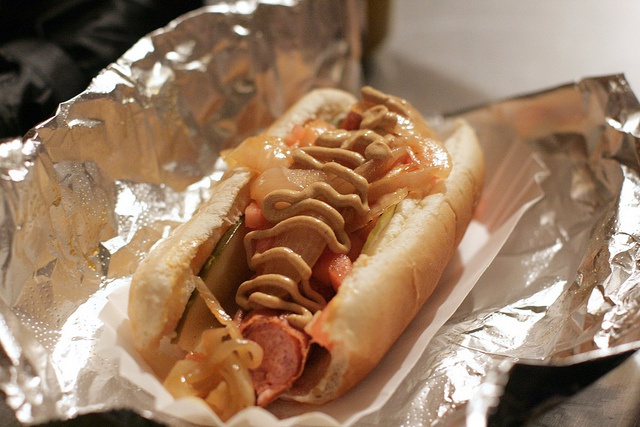Describe the objects in this image and their specific colors. I can see a hot dog in black, brown, maroon, and tan tones in this image. 